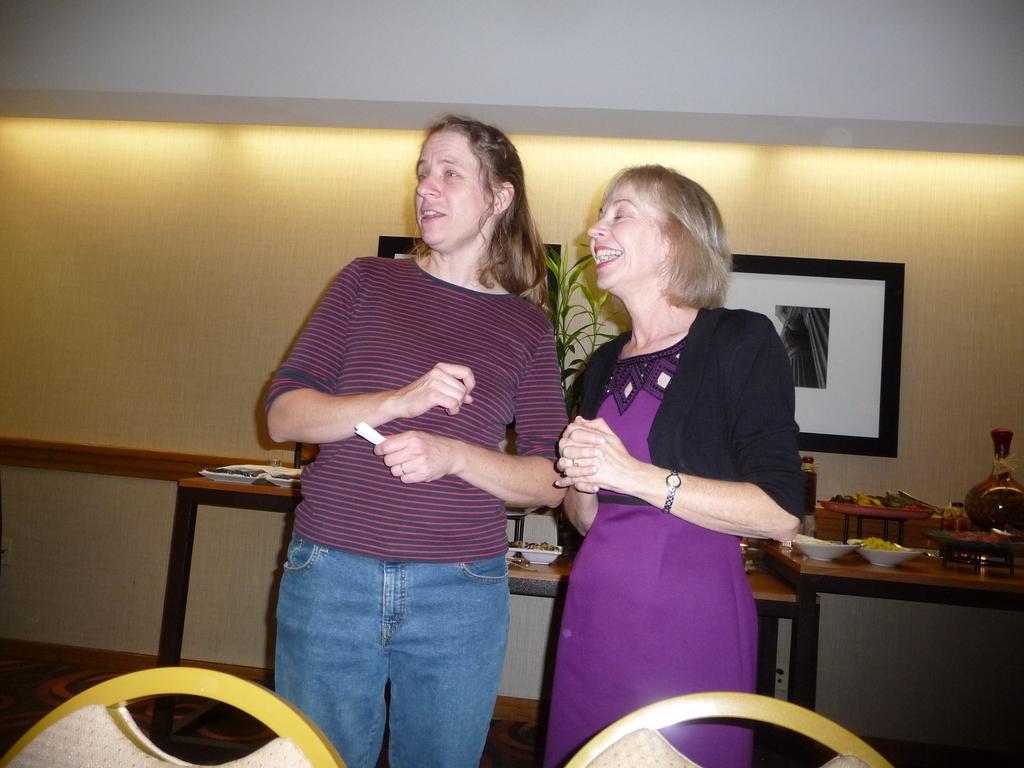In one or two sentences, can you explain what this image depicts? In this image there are two person standing beside a table. On the table we can see a cup, plates and some fruits. There is a painting on the wall. On the bottom there are two chairs. 